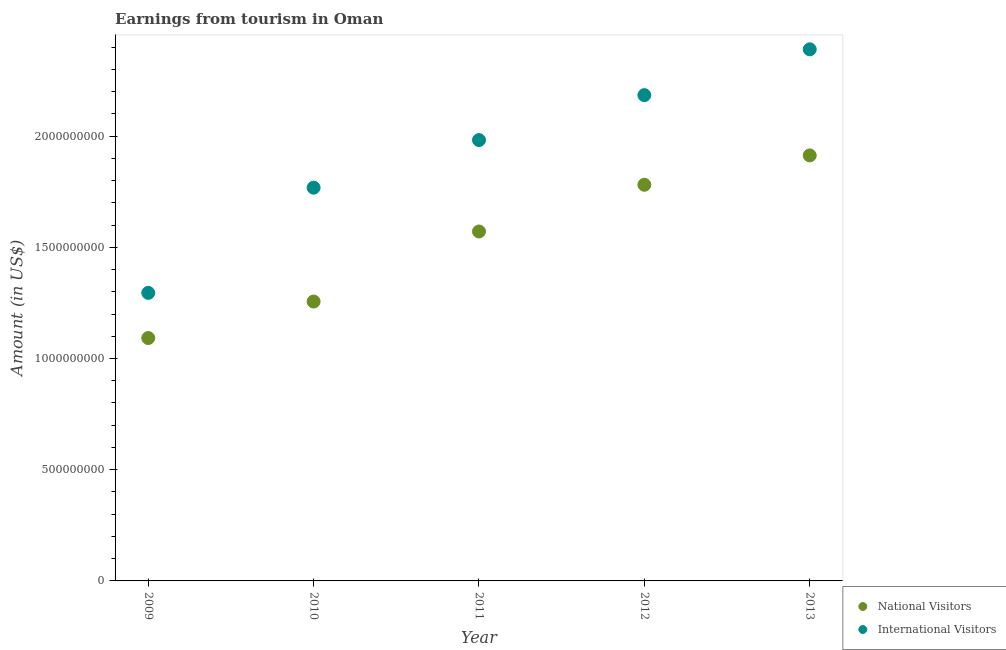What is the amount earned from international visitors in 2011?
Ensure brevity in your answer.  1.98e+09. Across all years, what is the maximum amount earned from national visitors?
Ensure brevity in your answer.  1.91e+09. Across all years, what is the minimum amount earned from national visitors?
Your answer should be very brief. 1.09e+09. In which year was the amount earned from international visitors maximum?
Provide a succinct answer. 2013. What is the total amount earned from international visitors in the graph?
Provide a succinct answer. 9.62e+09. What is the difference between the amount earned from international visitors in 2012 and that in 2013?
Your response must be concise. -2.06e+08. What is the difference between the amount earned from national visitors in 2011 and the amount earned from international visitors in 2012?
Ensure brevity in your answer.  -6.13e+08. What is the average amount earned from international visitors per year?
Ensure brevity in your answer.  1.92e+09. In the year 2012, what is the difference between the amount earned from international visitors and amount earned from national visitors?
Offer a very short reply. 4.03e+08. In how many years, is the amount earned from national visitors greater than 1500000000 US$?
Offer a very short reply. 3. What is the ratio of the amount earned from national visitors in 2011 to that in 2013?
Keep it short and to the point. 0.82. Is the amount earned from international visitors in 2011 less than that in 2013?
Make the answer very short. Yes. Is the difference between the amount earned from national visitors in 2010 and 2013 greater than the difference between the amount earned from international visitors in 2010 and 2013?
Keep it short and to the point. No. What is the difference between the highest and the second highest amount earned from national visitors?
Your response must be concise. 1.32e+08. What is the difference between the highest and the lowest amount earned from national visitors?
Your answer should be compact. 8.21e+08. How many dotlines are there?
Your answer should be compact. 2. Are the values on the major ticks of Y-axis written in scientific E-notation?
Ensure brevity in your answer.  No. Where does the legend appear in the graph?
Provide a succinct answer. Bottom right. How are the legend labels stacked?
Ensure brevity in your answer.  Vertical. What is the title of the graph?
Provide a short and direct response. Earnings from tourism in Oman. What is the label or title of the X-axis?
Your answer should be very brief. Year. What is the label or title of the Y-axis?
Keep it short and to the point. Amount (in US$). What is the Amount (in US$) in National Visitors in 2009?
Offer a terse response. 1.09e+09. What is the Amount (in US$) in International Visitors in 2009?
Your answer should be compact. 1.30e+09. What is the Amount (in US$) of National Visitors in 2010?
Offer a very short reply. 1.26e+09. What is the Amount (in US$) of International Visitors in 2010?
Keep it short and to the point. 1.77e+09. What is the Amount (in US$) of National Visitors in 2011?
Provide a succinct answer. 1.57e+09. What is the Amount (in US$) of International Visitors in 2011?
Offer a terse response. 1.98e+09. What is the Amount (in US$) in National Visitors in 2012?
Your answer should be compact. 1.78e+09. What is the Amount (in US$) of International Visitors in 2012?
Your response must be concise. 2.18e+09. What is the Amount (in US$) in National Visitors in 2013?
Make the answer very short. 1.91e+09. What is the Amount (in US$) in International Visitors in 2013?
Offer a terse response. 2.39e+09. Across all years, what is the maximum Amount (in US$) in National Visitors?
Provide a short and direct response. 1.91e+09. Across all years, what is the maximum Amount (in US$) in International Visitors?
Offer a terse response. 2.39e+09. Across all years, what is the minimum Amount (in US$) in National Visitors?
Your answer should be very brief. 1.09e+09. Across all years, what is the minimum Amount (in US$) in International Visitors?
Offer a very short reply. 1.30e+09. What is the total Amount (in US$) of National Visitors in the graph?
Give a very brief answer. 7.61e+09. What is the total Amount (in US$) of International Visitors in the graph?
Give a very brief answer. 9.62e+09. What is the difference between the Amount (in US$) in National Visitors in 2009 and that in 2010?
Your answer should be compact. -1.64e+08. What is the difference between the Amount (in US$) of International Visitors in 2009 and that in 2010?
Your answer should be very brief. -4.73e+08. What is the difference between the Amount (in US$) in National Visitors in 2009 and that in 2011?
Ensure brevity in your answer.  -4.79e+08. What is the difference between the Amount (in US$) of International Visitors in 2009 and that in 2011?
Your response must be concise. -6.87e+08. What is the difference between the Amount (in US$) in National Visitors in 2009 and that in 2012?
Your answer should be compact. -6.89e+08. What is the difference between the Amount (in US$) in International Visitors in 2009 and that in 2012?
Provide a short and direct response. -8.89e+08. What is the difference between the Amount (in US$) of National Visitors in 2009 and that in 2013?
Provide a succinct answer. -8.21e+08. What is the difference between the Amount (in US$) of International Visitors in 2009 and that in 2013?
Provide a short and direct response. -1.10e+09. What is the difference between the Amount (in US$) of National Visitors in 2010 and that in 2011?
Provide a succinct answer. -3.15e+08. What is the difference between the Amount (in US$) of International Visitors in 2010 and that in 2011?
Your answer should be very brief. -2.14e+08. What is the difference between the Amount (in US$) of National Visitors in 2010 and that in 2012?
Your answer should be compact. -5.25e+08. What is the difference between the Amount (in US$) in International Visitors in 2010 and that in 2012?
Your answer should be compact. -4.16e+08. What is the difference between the Amount (in US$) in National Visitors in 2010 and that in 2013?
Your answer should be very brief. -6.57e+08. What is the difference between the Amount (in US$) in International Visitors in 2010 and that in 2013?
Offer a very short reply. -6.22e+08. What is the difference between the Amount (in US$) in National Visitors in 2011 and that in 2012?
Offer a terse response. -2.10e+08. What is the difference between the Amount (in US$) of International Visitors in 2011 and that in 2012?
Provide a short and direct response. -2.02e+08. What is the difference between the Amount (in US$) of National Visitors in 2011 and that in 2013?
Your answer should be very brief. -3.42e+08. What is the difference between the Amount (in US$) of International Visitors in 2011 and that in 2013?
Provide a short and direct response. -4.08e+08. What is the difference between the Amount (in US$) of National Visitors in 2012 and that in 2013?
Provide a succinct answer. -1.32e+08. What is the difference between the Amount (in US$) in International Visitors in 2012 and that in 2013?
Your response must be concise. -2.06e+08. What is the difference between the Amount (in US$) in National Visitors in 2009 and the Amount (in US$) in International Visitors in 2010?
Provide a short and direct response. -6.76e+08. What is the difference between the Amount (in US$) in National Visitors in 2009 and the Amount (in US$) in International Visitors in 2011?
Give a very brief answer. -8.90e+08. What is the difference between the Amount (in US$) in National Visitors in 2009 and the Amount (in US$) in International Visitors in 2012?
Offer a terse response. -1.09e+09. What is the difference between the Amount (in US$) in National Visitors in 2009 and the Amount (in US$) in International Visitors in 2013?
Make the answer very short. -1.30e+09. What is the difference between the Amount (in US$) in National Visitors in 2010 and the Amount (in US$) in International Visitors in 2011?
Make the answer very short. -7.26e+08. What is the difference between the Amount (in US$) of National Visitors in 2010 and the Amount (in US$) of International Visitors in 2012?
Ensure brevity in your answer.  -9.28e+08. What is the difference between the Amount (in US$) in National Visitors in 2010 and the Amount (in US$) in International Visitors in 2013?
Keep it short and to the point. -1.13e+09. What is the difference between the Amount (in US$) in National Visitors in 2011 and the Amount (in US$) in International Visitors in 2012?
Your answer should be compact. -6.13e+08. What is the difference between the Amount (in US$) in National Visitors in 2011 and the Amount (in US$) in International Visitors in 2013?
Give a very brief answer. -8.19e+08. What is the difference between the Amount (in US$) in National Visitors in 2012 and the Amount (in US$) in International Visitors in 2013?
Provide a short and direct response. -6.09e+08. What is the average Amount (in US$) of National Visitors per year?
Your answer should be compact. 1.52e+09. What is the average Amount (in US$) of International Visitors per year?
Your answer should be very brief. 1.92e+09. In the year 2009, what is the difference between the Amount (in US$) in National Visitors and Amount (in US$) in International Visitors?
Offer a very short reply. -2.03e+08. In the year 2010, what is the difference between the Amount (in US$) of National Visitors and Amount (in US$) of International Visitors?
Your answer should be very brief. -5.12e+08. In the year 2011, what is the difference between the Amount (in US$) in National Visitors and Amount (in US$) in International Visitors?
Ensure brevity in your answer.  -4.11e+08. In the year 2012, what is the difference between the Amount (in US$) in National Visitors and Amount (in US$) in International Visitors?
Provide a short and direct response. -4.03e+08. In the year 2013, what is the difference between the Amount (in US$) in National Visitors and Amount (in US$) in International Visitors?
Your answer should be compact. -4.77e+08. What is the ratio of the Amount (in US$) in National Visitors in 2009 to that in 2010?
Provide a short and direct response. 0.87. What is the ratio of the Amount (in US$) of International Visitors in 2009 to that in 2010?
Offer a terse response. 0.73. What is the ratio of the Amount (in US$) in National Visitors in 2009 to that in 2011?
Provide a succinct answer. 0.7. What is the ratio of the Amount (in US$) of International Visitors in 2009 to that in 2011?
Your answer should be very brief. 0.65. What is the ratio of the Amount (in US$) in National Visitors in 2009 to that in 2012?
Your response must be concise. 0.61. What is the ratio of the Amount (in US$) of International Visitors in 2009 to that in 2012?
Offer a very short reply. 0.59. What is the ratio of the Amount (in US$) in National Visitors in 2009 to that in 2013?
Offer a terse response. 0.57. What is the ratio of the Amount (in US$) in International Visitors in 2009 to that in 2013?
Offer a very short reply. 0.54. What is the ratio of the Amount (in US$) of National Visitors in 2010 to that in 2011?
Offer a terse response. 0.8. What is the ratio of the Amount (in US$) of International Visitors in 2010 to that in 2011?
Offer a terse response. 0.89. What is the ratio of the Amount (in US$) of National Visitors in 2010 to that in 2012?
Your response must be concise. 0.71. What is the ratio of the Amount (in US$) of International Visitors in 2010 to that in 2012?
Provide a short and direct response. 0.81. What is the ratio of the Amount (in US$) of National Visitors in 2010 to that in 2013?
Provide a short and direct response. 0.66. What is the ratio of the Amount (in US$) of International Visitors in 2010 to that in 2013?
Ensure brevity in your answer.  0.74. What is the ratio of the Amount (in US$) of National Visitors in 2011 to that in 2012?
Make the answer very short. 0.88. What is the ratio of the Amount (in US$) in International Visitors in 2011 to that in 2012?
Your response must be concise. 0.91. What is the ratio of the Amount (in US$) in National Visitors in 2011 to that in 2013?
Provide a short and direct response. 0.82. What is the ratio of the Amount (in US$) in International Visitors in 2011 to that in 2013?
Make the answer very short. 0.83. What is the ratio of the Amount (in US$) in International Visitors in 2012 to that in 2013?
Ensure brevity in your answer.  0.91. What is the difference between the highest and the second highest Amount (in US$) of National Visitors?
Ensure brevity in your answer.  1.32e+08. What is the difference between the highest and the second highest Amount (in US$) of International Visitors?
Keep it short and to the point. 2.06e+08. What is the difference between the highest and the lowest Amount (in US$) of National Visitors?
Your answer should be compact. 8.21e+08. What is the difference between the highest and the lowest Amount (in US$) in International Visitors?
Your answer should be compact. 1.10e+09. 